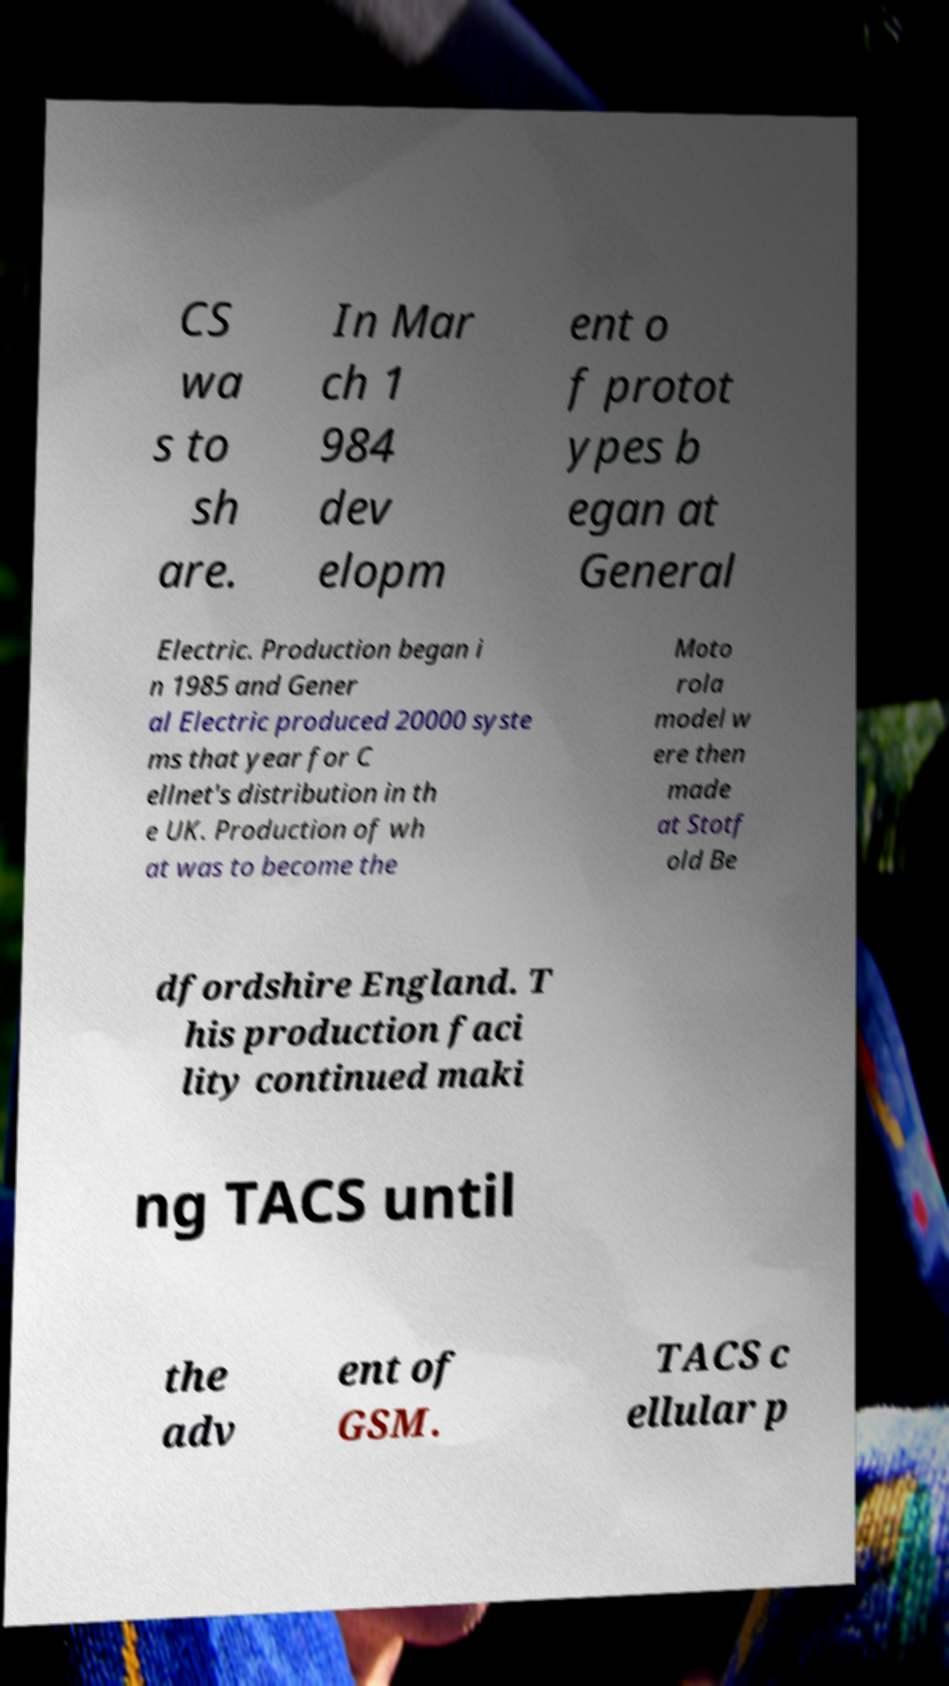Please identify and transcribe the text found in this image. CS wa s to sh are. In Mar ch 1 984 dev elopm ent o f protot ypes b egan at General Electric. Production began i n 1985 and Gener al Electric produced 20000 syste ms that year for C ellnet's distribution in th e UK. Production of wh at was to become the Moto rola model w ere then made at Stotf old Be dfordshire England. T his production faci lity continued maki ng TACS until the adv ent of GSM. TACS c ellular p 